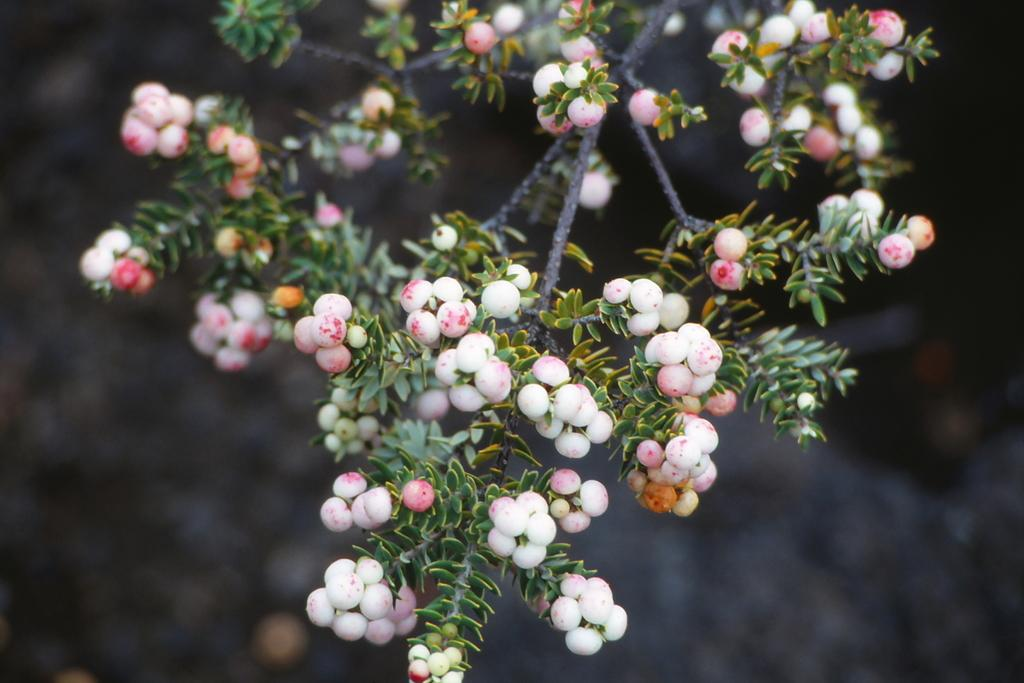What is present in the picture? There is a plant in the picture. What can be observed about the fruits on the plant? The plant has white color fruits. What else is part of the plant's structure? The plant has leaves. How would you describe the background of the image? The backdrop of the image is blurred. What is the weight of the plant in the image? The weight of the plant cannot be determined from the image alone, as it does not provide any information about the size or mass of the plant. 